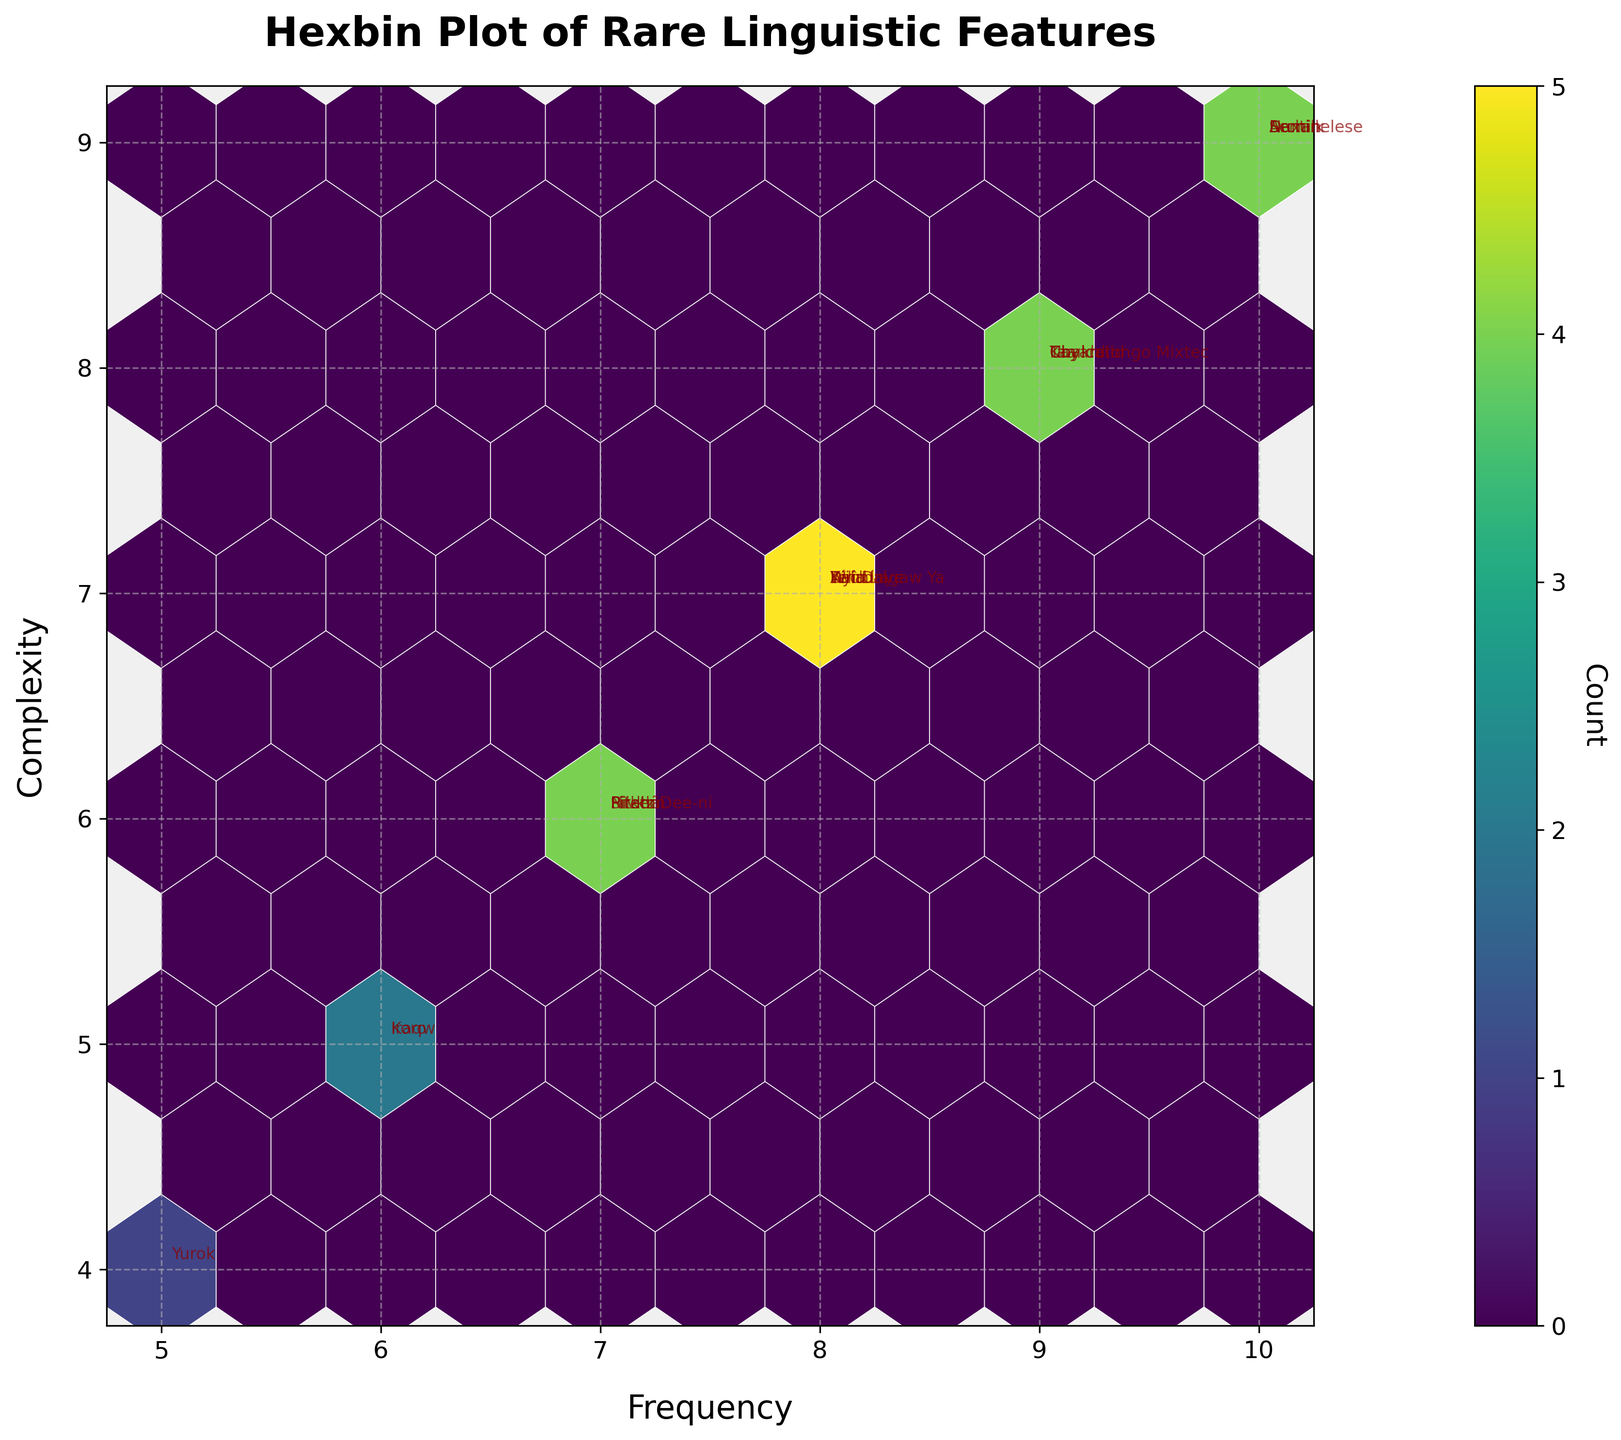What is the title of the hexbin plot? The title of a plot is typically found at the top and visually represents the overall subject of the plot. In this case, it states, "Hexbin Plot of Rare Linguistic Features," which clearly indicates the focus is on plotting the rarity and complexity of linguistic features.
Answer: Hexbin Plot of Rare Linguistic Features Which language has the highest complexity and frequency values? The hexbin plot labels each data point with the name of the language. The data point at the top-right corner of the plot with the highest values for both x (Frequency) and y (Complexity) is labeled. According to the data, this language is "Nuxalk" with values (Frequency=10, Complexity=9).
Answer: Nuxalk What is the average frequency of the linguistic features in the plot? To find the average, sum the frequencies of all linguistic features and then divide by the number of features. Summing the given frequencies: 8 + 9 + 7 + 10 + 9 + 8 + 10 + 6 + 7 + 5 + 8 + 6 + 9 + 7 + 8 + 9 + 10 + 8 + 7 = 157. There are 19 data points, so the average is 157/19.
Answer: 8.26 How many hexagonal bins have been created in the plot? The hexbin plot uses hexagonal bins to group data points. Each bin is visible as a hexagon on the plot. Counting the total number of hexagons filled with color on the plot gives the number of bins used. Given the grid size is set to 10, we examine the plotted graph to count the active hexagons.
Answer: Determinable from figure Compare the occurrence of grammatical cases in "Archi" with the occurrence of tonal systems in "Pirahã." Which has a higher frequency? "Archi" has a frequency value and complexity, as labeled on the plot. Similarly, "Pirahã" has its own values. Extracting and comparing these frequencies, the higher one indicates the higher occurrence. Archi (Frequency=10), Pirahã (Frequency=7)
Answer: Archi Which linguistic feature has a complexity of 5 and a frequency of 6? The plot labels each data point, and by looking at the coordinates where x=6 and y=5, we can match this to a specific language. According to the data, the corresponding linguistic feature would be labeled as "Koro".
Answer: Koro Calculate the total count of languages having frequency greater than 8. From the figure, identify all data points where the x-axis value (Frequency) is greater than 8. Count these data points to get the total. The corresponding frequencies are counts for values above 8 as seen in the data and plot labels.
Answer: 6 Which linguistic feature does not cluster with others in terms of complexity and frequency? Analyzing the hexbin plot, identify outlier data points that are not grouped with others within the hexagonal bins, making them visually distinct. Locate the coordinates and cross-check with data.
Answer: Determinable from figure What does the color intensity in the hexagonal bins represent? In a hexbin plot, the color intensity often indicates the number of data points within each bin. Darker colors represent higher counts, while lighter colors indicate fewer counts. This interp relation can be directly observed from the color bar provided in the plot.
Answer: Count of data points 